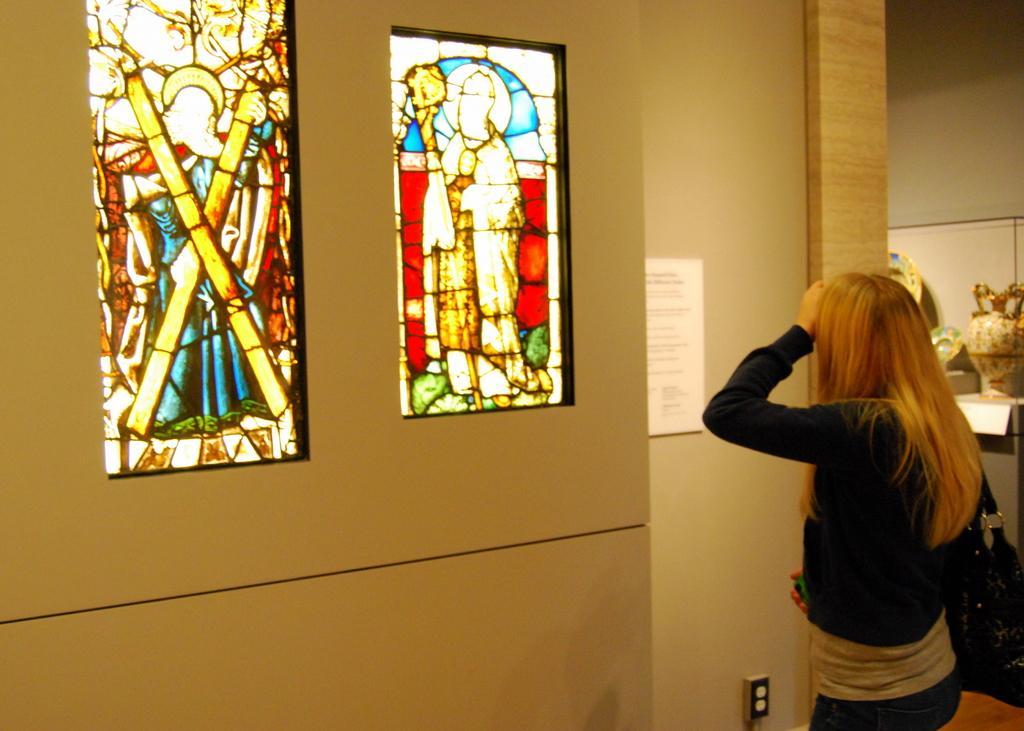Could you give a brief overview of what you see in this image? This image consists of a woman wearing black jacket. To the left, there is a wall on which there are two frames. To the right, there is a pot made up of ceramic. 